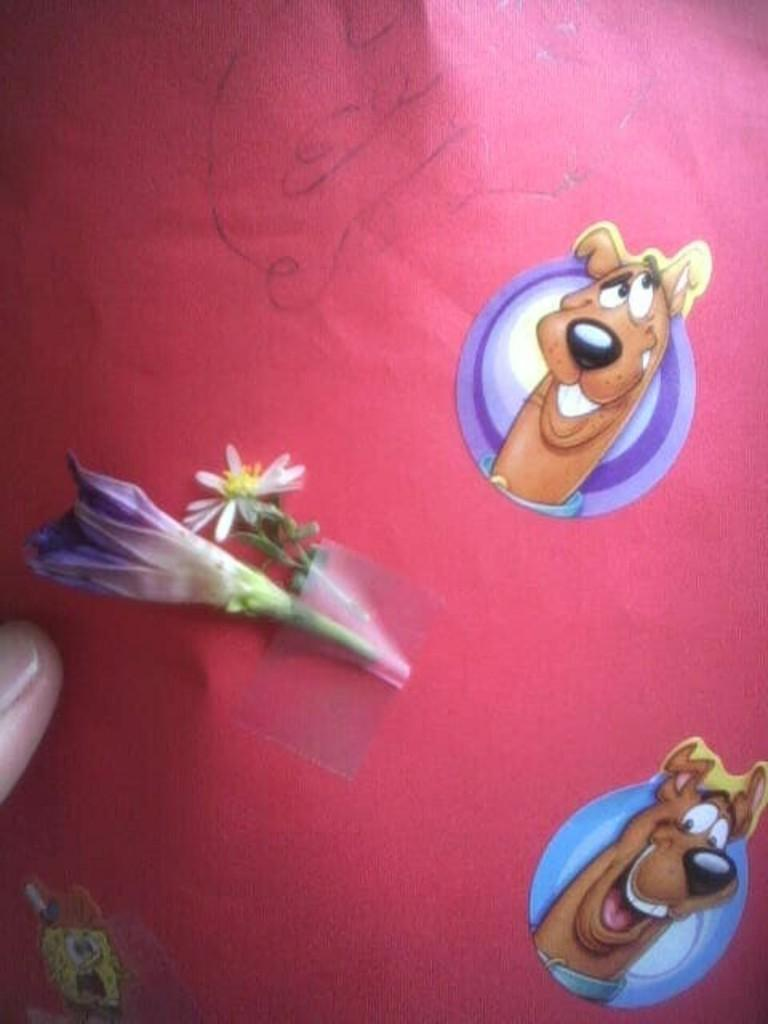What is on the red surface in the image? There are two stickers and a flower on the red surface in the image. Can you describe the stickers on the red surface? Unfortunately, the details of the stickers cannot be determined from the provided facts. What else is visible on the red surface? A person's finger is visible in the image. What type of linen is being used to clean the flower in the image? There is no linen present in the image, nor is there any indication that the flower is being cleaned. 